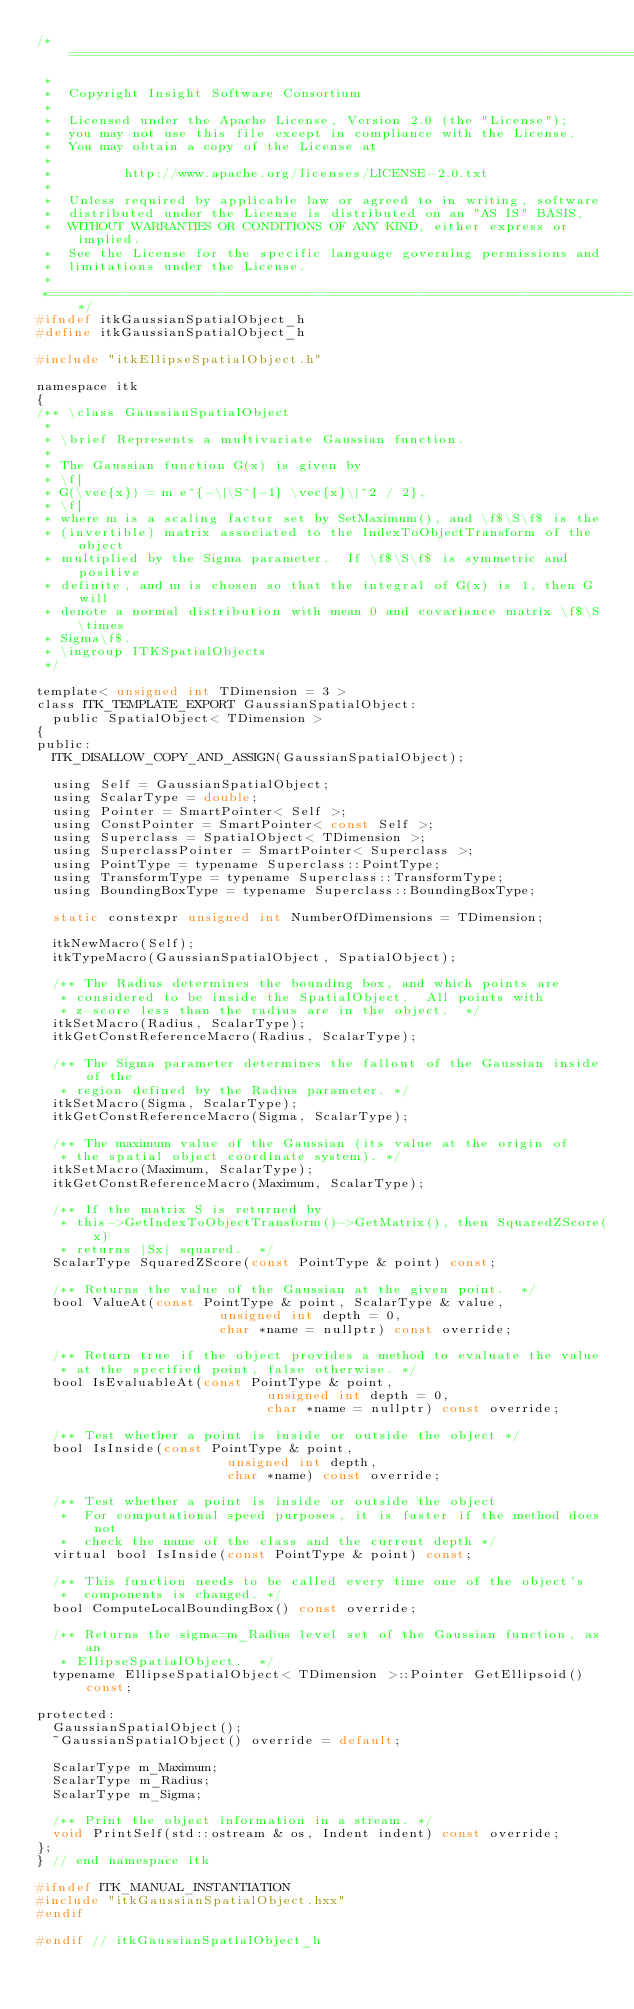Convert code to text. <code><loc_0><loc_0><loc_500><loc_500><_C_>/*=========================================================================
 *
 *  Copyright Insight Software Consortium
 *
 *  Licensed under the Apache License, Version 2.0 (the "License");
 *  you may not use this file except in compliance with the License.
 *  You may obtain a copy of the License at
 *
 *         http://www.apache.org/licenses/LICENSE-2.0.txt
 *
 *  Unless required by applicable law or agreed to in writing, software
 *  distributed under the License is distributed on an "AS IS" BASIS,
 *  WITHOUT WARRANTIES OR CONDITIONS OF ANY KIND, either express or implied.
 *  See the License for the specific language governing permissions and
 *  limitations under the License.
 *
 *=========================================================================*/
#ifndef itkGaussianSpatialObject_h
#define itkGaussianSpatialObject_h

#include "itkEllipseSpatialObject.h"

namespace itk
{
/** \class GaussianSpatialObject
 *
 * \brief Represents a multivariate Gaussian function.
 *
 * The Gaussian function G(x) is given by
 * \f[
 * G(\vec{x}) = m e^{-\|\S^{-1} \vec{x}\|^2 / 2},
 * \f]
 * where m is a scaling factor set by SetMaximum(), and \f$\S\f$ is the
 * (invertible) matrix associated to the IndexToObjectTransform of the object
 * multiplied by the Sigma parameter.  If \f$\S\f$ is symmetric and positive
 * definite, and m is chosen so that the integral of G(x) is 1, then G will
 * denote a normal distribution with mean 0 and covariance matrix \f$\S \times
 * Sigma\f$.
 * \ingroup ITKSpatialObjects
 */

template< unsigned int TDimension = 3 >
class ITK_TEMPLATE_EXPORT GaussianSpatialObject:
  public SpatialObject< TDimension >
{
public:
  ITK_DISALLOW_COPY_AND_ASSIGN(GaussianSpatialObject);

  using Self = GaussianSpatialObject;
  using ScalarType = double;
  using Pointer = SmartPointer< Self >;
  using ConstPointer = SmartPointer< const Self >;
  using Superclass = SpatialObject< TDimension >;
  using SuperclassPointer = SmartPointer< Superclass >;
  using PointType = typename Superclass::PointType;
  using TransformType = typename Superclass::TransformType;
  using BoundingBoxType = typename Superclass::BoundingBoxType;

  static constexpr unsigned int NumberOfDimensions = TDimension;

  itkNewMacro(Self);
  itkTypeMacro(GaussianSpatialObject, SpatialObject);

  /** The Radius determines the bounding box, and which points are
   * considered to be inside the SpatialObject.  All points with
   * z-score less than the radius are in the object.  */
  itkSetMacro(Radius, ScalarType);
  itkGetConstReferenceMacro(Radius, ScalarType);

  /** The Sigma parameter determines the fallout of the Gaussian inside of the
   * region defined by the Radius parameter. */
  itkSetMacro(Sigma, ScalarType);
  itkGetConstReferenceMacro(Sigma, ScalarType);

  /** The maximum value of the Gaussian (its value at the origin of
   * the spatial object coordinate system). */
  itkSetMacro(Maximum, ScalarType);
  itkGetConstReferenceMacro(Maximum, ScalarType);

  /** If the matrix S is returned by
   * this->GetIndexToObjectTransform()->GetMatrix(), then SquaredZScore(x)
   * returns |Sx| squared.  */
  ScalarType SquaredZScore(const PointType & point) const;

  /** Returns the value of the Gaussian at the given point.  */
  bool ValueAt(const PointType & point, ScalarType & value,
                       unsigned int depth = 0,
                       char *name = nullptr) const override;

  /** Return true if the object provides a method to evaluate the value
   * at the specified point, false otherwise. */
  bool IsEvaluableAt(const PointType & point,
                             unsigned int depth = 0,
                             char *name = nullptr) const override;

  /** Test whether a point is inside or outside the object */
  bool IsInside(const PointType & point,
                        unsigned int depth,
                        char *name) const override;

  /** Test whether a point is inside or outside the object
   *  For computational speed purposes, it is faster if the method does not
   *  check the name of the class and the current depth */
  virtual bool IsInside(const PointType & point) const;

  /** This function needs to be called every time one of the object's
   *  components is changed. */
  bool ComputeLocalBoundingBox() const override;

  /** Returns the sigma=m_Radius level set of the Gaussian function, as an
   * EllipseSpatialObject.  */
  typename EllipseSpatialObject< TDimension >::Pointer GetEllipsoid() const;

protected:
  GaussianSpatialObject();
  ~GaussianSpatialObject() override = default;

  ScalarType m_Maximum;
  ScalarType m_Radius;
  ScalarType m_Sigma;

  /** Print the object information in a stream. */
  void PrintSelf(std::ostream & os, Indent indent) const override;
};
} // end namespace itk

#ifndef ITK_MANUAL_INSTANTIATION
#include "itkGaussianSpatialObject.hxx"
#endif

#endif // itkGaussianSpatialObject_h
</code> 